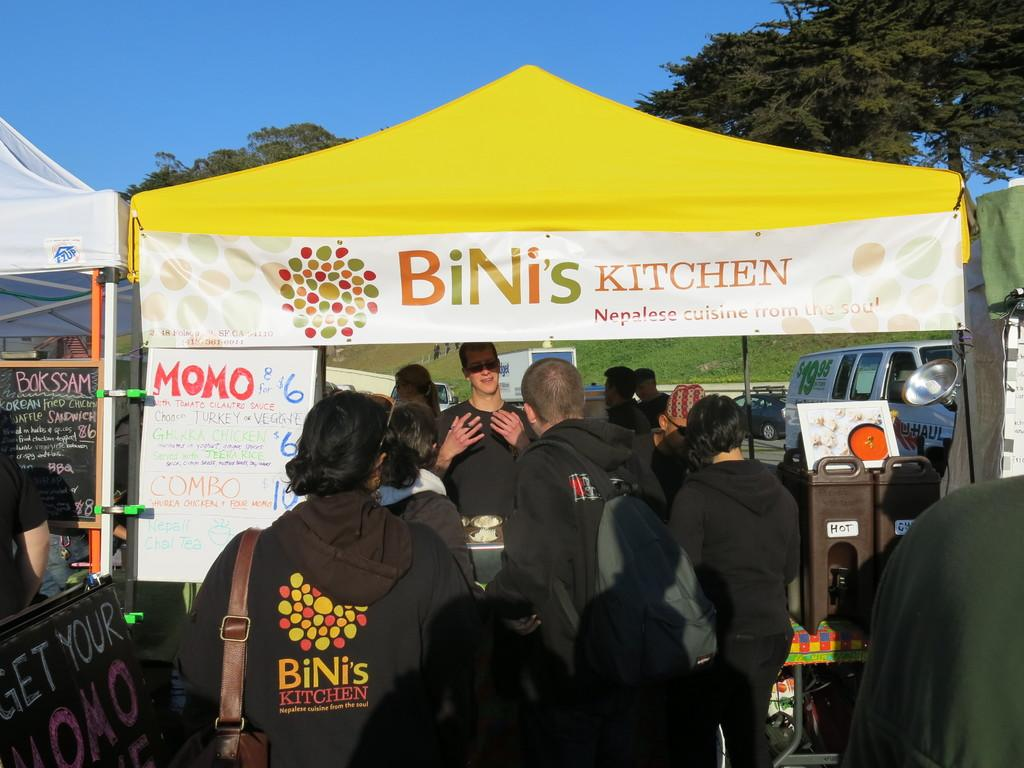What can be seen in the image involving people? There are people standing in the image. What type of temporary shelter is present in the image? There are tents in the image. What mode of transportation can be seen in the image? There are cars in the image. What type of natural vegetation is present in the image? There are trees in the image. What is visible in the background of the image? The sky is visible in the image. Where is the cup placed in the image? There is no cup present in the image. What type of clothing accessory is draped over the tents in the image? There is no veil present in the image; it does not mention any clothing accessories. 